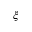Convert formula to latex. <formula><loc_0><loc_0><loc_500><loc_500>{ \boldsymbol \xi }</formula> 